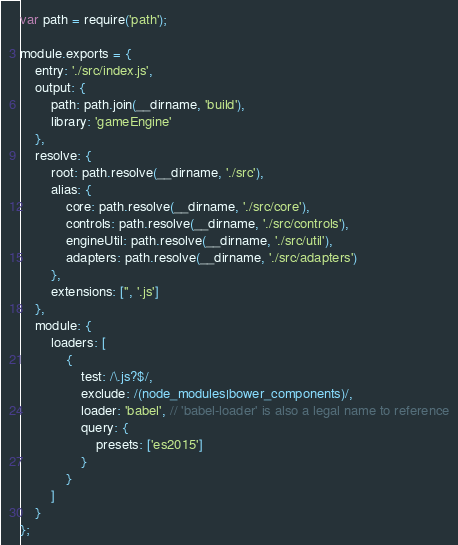Convert code to text. <code><loc_0><loc_0><loc_500><loc_500><_JavaScript_>var path = require('path');

module.exports = {
    entry: './src/index.js',
    output: {
        path: path.join(__dirname, 'build'),
        library: 'gameEngine'
    },
    resolve: {
        root: path.resolve(__dirname, './src'),
        alias: {
            core: path.resolve(__dirname, './src/core'),
            controls: path.resolve(__dirname, './src/controls'),
            engineUtil: path.resolve(__dirname, './src/util'),
            adapters: path.resolve(__dirname, './src/adapters')
        },
        extensions: ['', '.js']
    },
    module: {
        loaders: [
            {
                test: /\.js?$/,
                exclude: /(node_modules|bower_components)/,
                loader: 'babel', // 'babel-loader' is also a legal name to reference
                query: {
                    presets: ['es2015']
                }
            }
        ]
    }
};</code> 